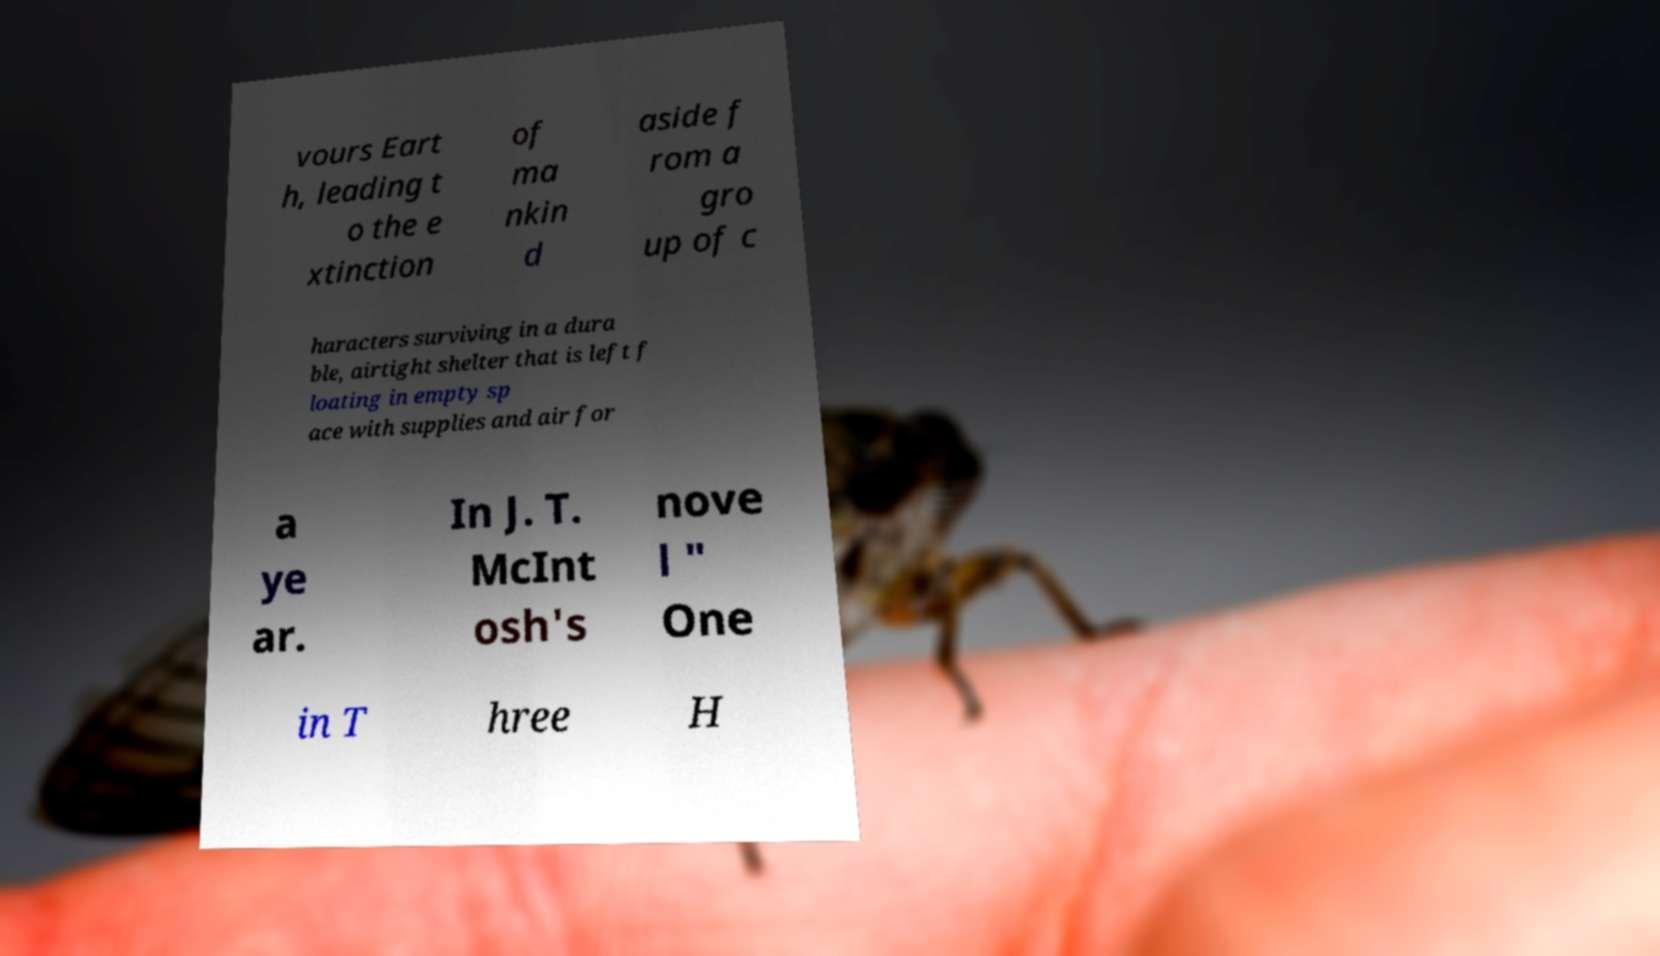I need the written content from this picture converted into text. Can you do that? vours Eart h, leading t o the e xtinction of ma nkin d aside f rom a gro up of c haracters surviving in a dura ble, airtight shelter that is left f loating in empty sp ace with supplies and air for a ye ar. In J. T. McInt osh's nove l " One in T hree H 